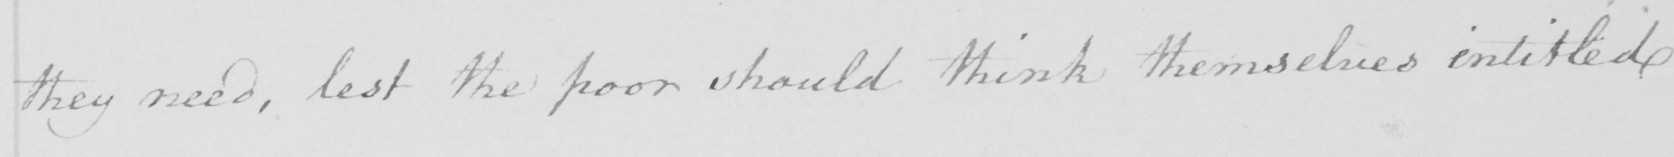What does this handwritten line say? they need , lest the poor should think themselves entitled 